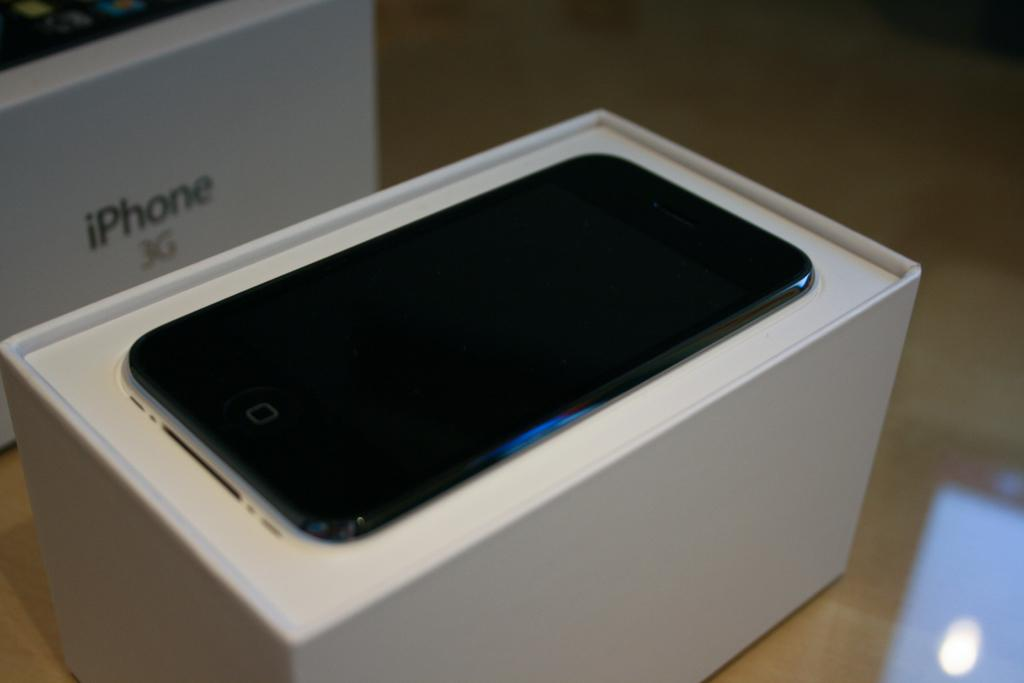<image>
Give a short and clear explanation of the subsequent image. A box on display with an Iphone sitting on a desk. 